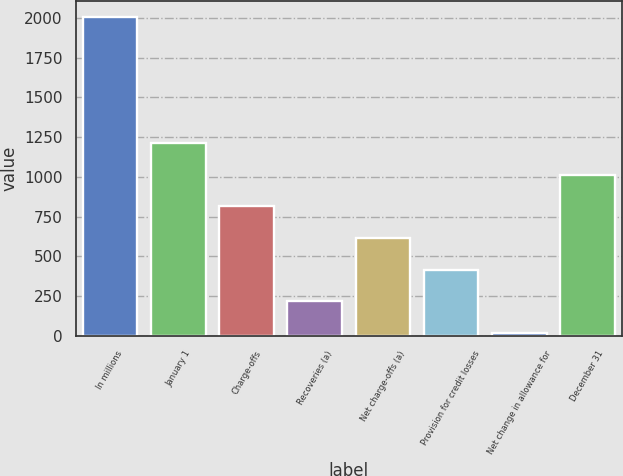<chart> <loc_0><loc_0><loc_500><loc_500><bar_chart><fcel>In millions<fcel>January 1<fcel>Charge-offs<fcel>Recoveries (a)<fcel>Net charge-offs (a)<fcel>Provision for credit losses<fcel>Net change in allowance for<fcel>December 31<nl><fcel>2006<fcel>1211.6<fcel>814.4<fcel>218.6<fcel>615.8<fcel>417.2<fcel>20<fcel>1013<nl></chart> 